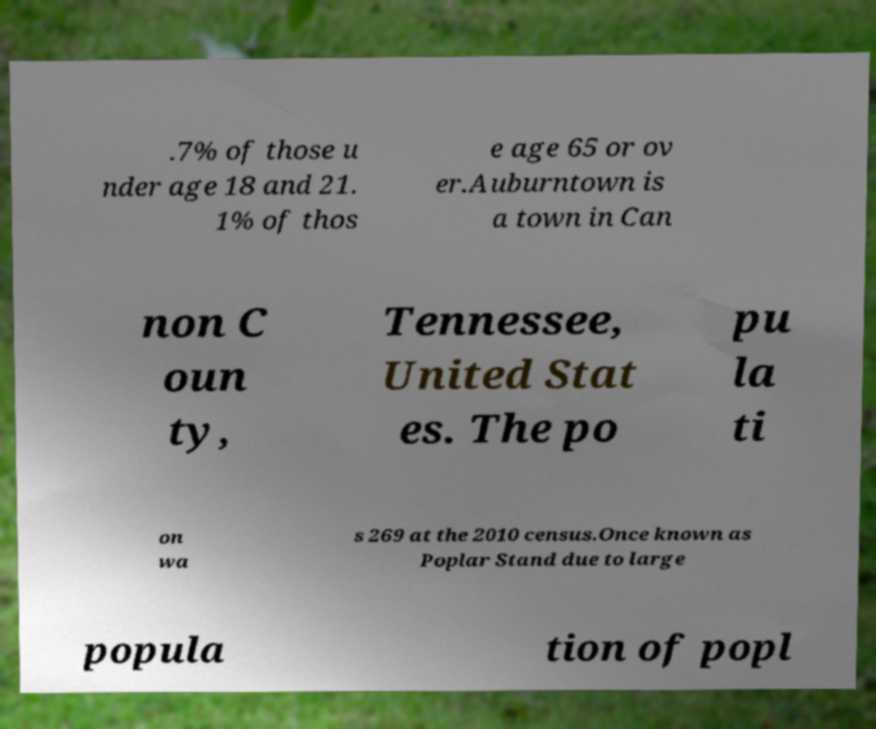What messages or text are displayed in this image? I need them in a readable, typed format. .7% of those u nder age 18 and 21. 1% of thos e age 65 or ov er.Auburntown is a town in Can non C oun ty, Tennessee, United Stat es. The po pu la ti on wa s 269 at the 2010 census.Once known as Poplar Stand due to large popula tion of popl 